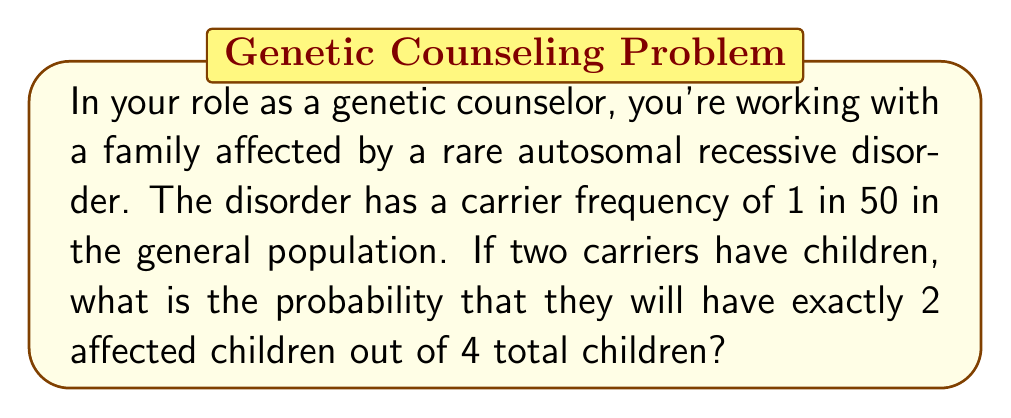Solve this math problem. Let's approach this step-by-step:

1) First, we need to understand the probability of having an affected child when both parents are carriers:
   - The probability of an affected child (both recessive alleles) is $\frac{1}{4}$
   - The probability of an unaffected child is $\frac{3}{4}$

2) We're looking for the probability of exactly 2 affected children out of 4. This follows a binomial distribution.

3) The probability mass function for a binomial distribution is:

   $$ P(X = k) = \binom{n}{k} p^k (1-p)^{n-k} $$

   Where:
   $n$ = number of trials (4 children)
   $k$ = number of successes (2 affected children)
   $p$ = probability of success on each trial ($\frac{1}{4}$)

4) Let's substitute these values:

   $$ P(X = 2) = \binom{4}{2} (\frac{1}{4})^2 (\frac{3}{4})^{4-2} $$

5) Simplify:
   $$ P(X = 2) = 6 \cdot (\frac{1}{16}) \cdot (\frac{9}{16}) $$

6) Calculate:
   $$ P(X = 2) = 6 \cdot \frac{9}{256} = \frac{54}{256} = \frac{27}{128} \approx 0.2109 $$

Therefore, the probability of having exactly 2 affected children out of 4 is $\frac{27}{128}$ or about 21.09%.
Answer: $\frac{27}{128}$ 